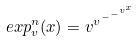Convert formula to latex. <formula><loc_0><loc_0><loc_500><loc_500>e x p _ { v } ^ { n } ( x ) = v ^ { v ^ { - ^ { - ^ { v ^ { x } } } } }</formula> 